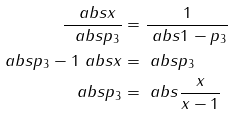Convert formula to latex. <formula><loc_0><loc_0><loc_500><loc_500>\frac { \ a b s { x } } { \ a b s { p _ { 3 } } } & = \frac { 1 } { \ a b s { 1 - p _ { 3 } } } \\ \ a b s { p _ { 3 } - 1 } \ a b s { x } & = \ a b s { p _ { 3 } } \\ \ a b s { p _ { 3 } } & = \ a b s { \frac { x } { x - 1 } }</formula> 